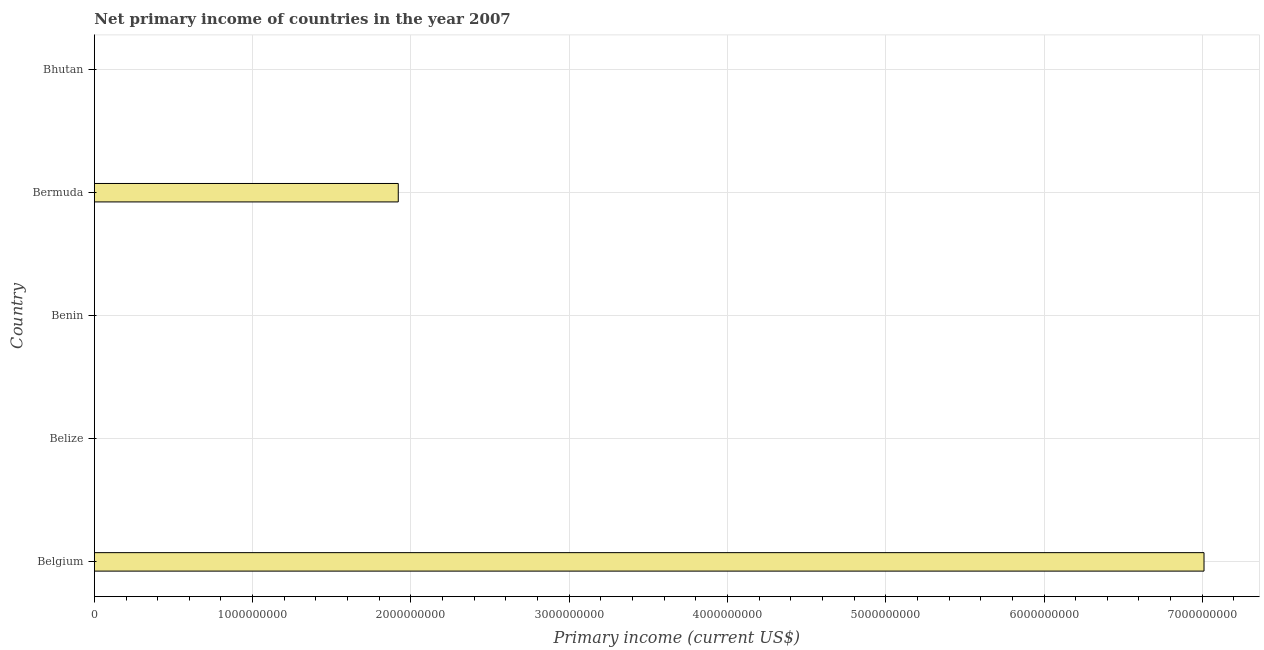Does the graph contain any zero values?
Your answer should be very brief. Yes. Does the graph contain grids?
Provide a succinct answer. Yes. What is the title of the graph?
Keep it short and to the point. Net primary income of countries in the year 2007. What is the label or title of the X-axis?
Provide a short and direct response. Primary income (current US$). What is the amount of primary income in Benin?
Your answer should be compact. 0. Across all countries, what is the maximum amount of primary income?
Your answer should be very brief. 7.01e+09. In which country was the amount of primary income maximum?
Your answer should be very brief. Belgium. What is the sum of the amount of primary income?
Ensure brevity in your answer.  8.93e+09. What is the difference between the amount of primary income in Belgium and Bermuda?
Give a very brief answer. 5.09e+09. What is the average amount of primary income per country?
Offer a very short reply. 1.79e+09. What is the difference between the highest and the lowest amount of primary income?
Offer a terse response. 7.01e+09. In how many countries, is the amount of primary income greater than the average amount of primary income taken over all countries?
Provide a succinct answer. 2. What is the Primary income (current US$) of Belgium?
Give a very brief answer. 7.01e+09. What is the Primary income (current US$) in Bermuda?
Keep it short and to the point. 1.92e+09. What is the Primary income (current US$) in Bhutan?
Offer a very short reply. 0. What is the difference between the Primary income (current US$) in Belgium and Bermuda?
Offer a very short reply. 5.09e+09. What is the ratio of the Primary income (current US$) in Belgium to that in Bermuda?
Your response must be concise. 3.65. 